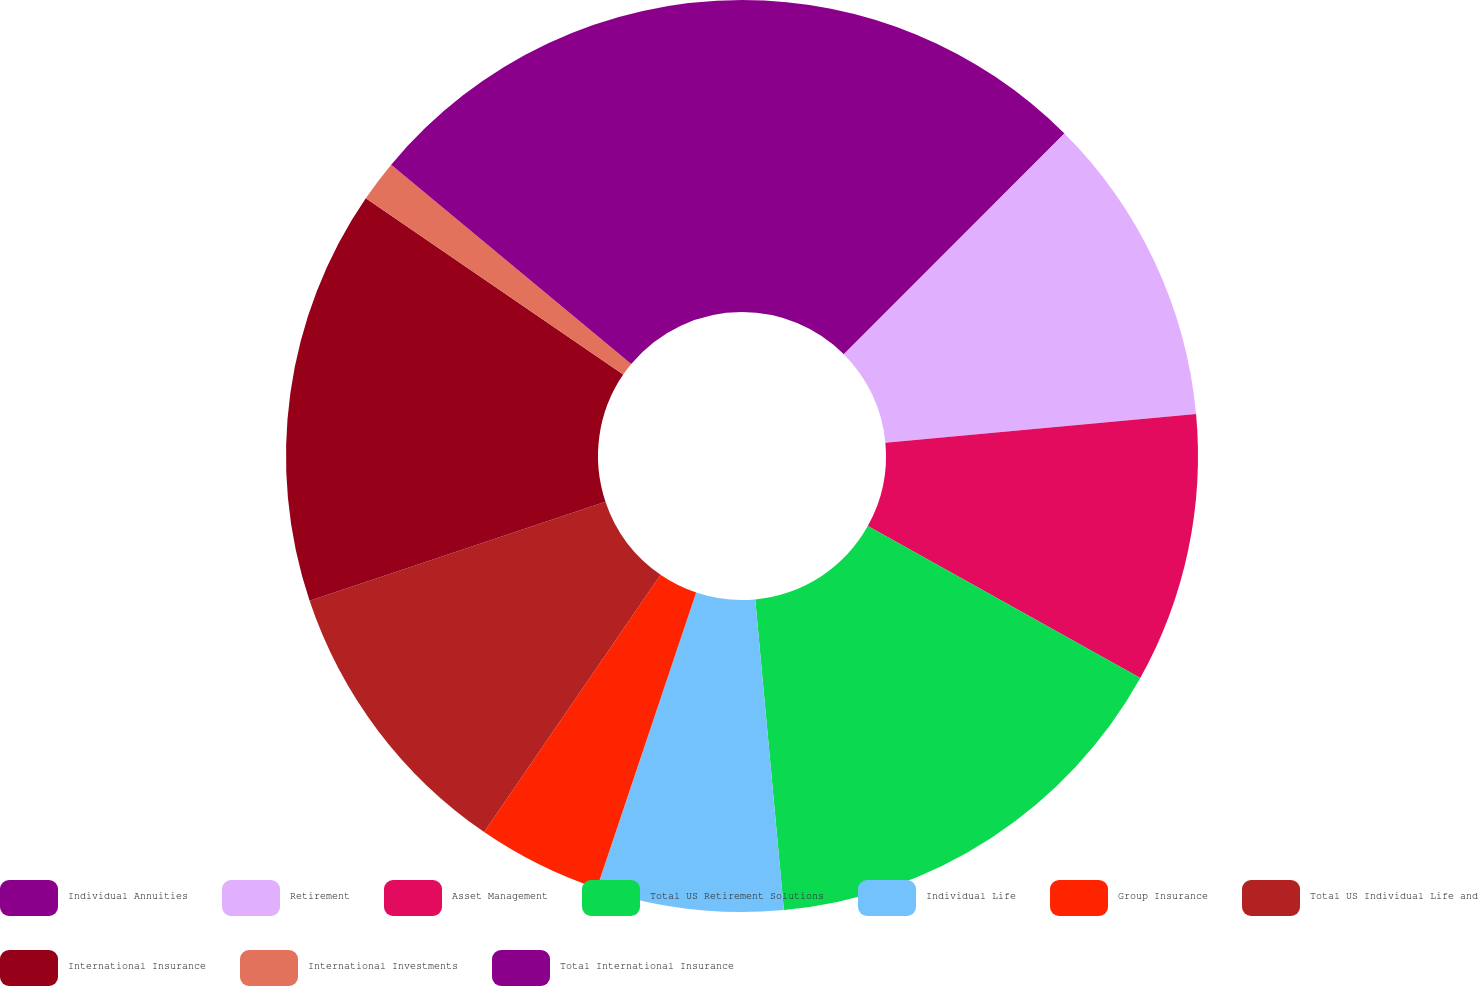Convert chart. <chart><loc_0><loc_0><loc_500><loc_500><pie_chart><fcel>Individual Annuities<fcel>Retirement<fcel>Asset Management<fcel>Total US Retirement Solutions<fcel>Individual Life<fcel>Group Insurance<fcel>Total US Individual Life and<fcel>International Insurance<fcel>International Investments<fcel>Total International Insurance<nl><fcel>12.5%<fcel>11.03%<fcel>9.56%<fcel>15.44%<fcel>6.62%<fcel>4.41%<fcel>10.29%<fcel>14.7%<fcel>1.47%<fcel>13.97%<nl></chart> 